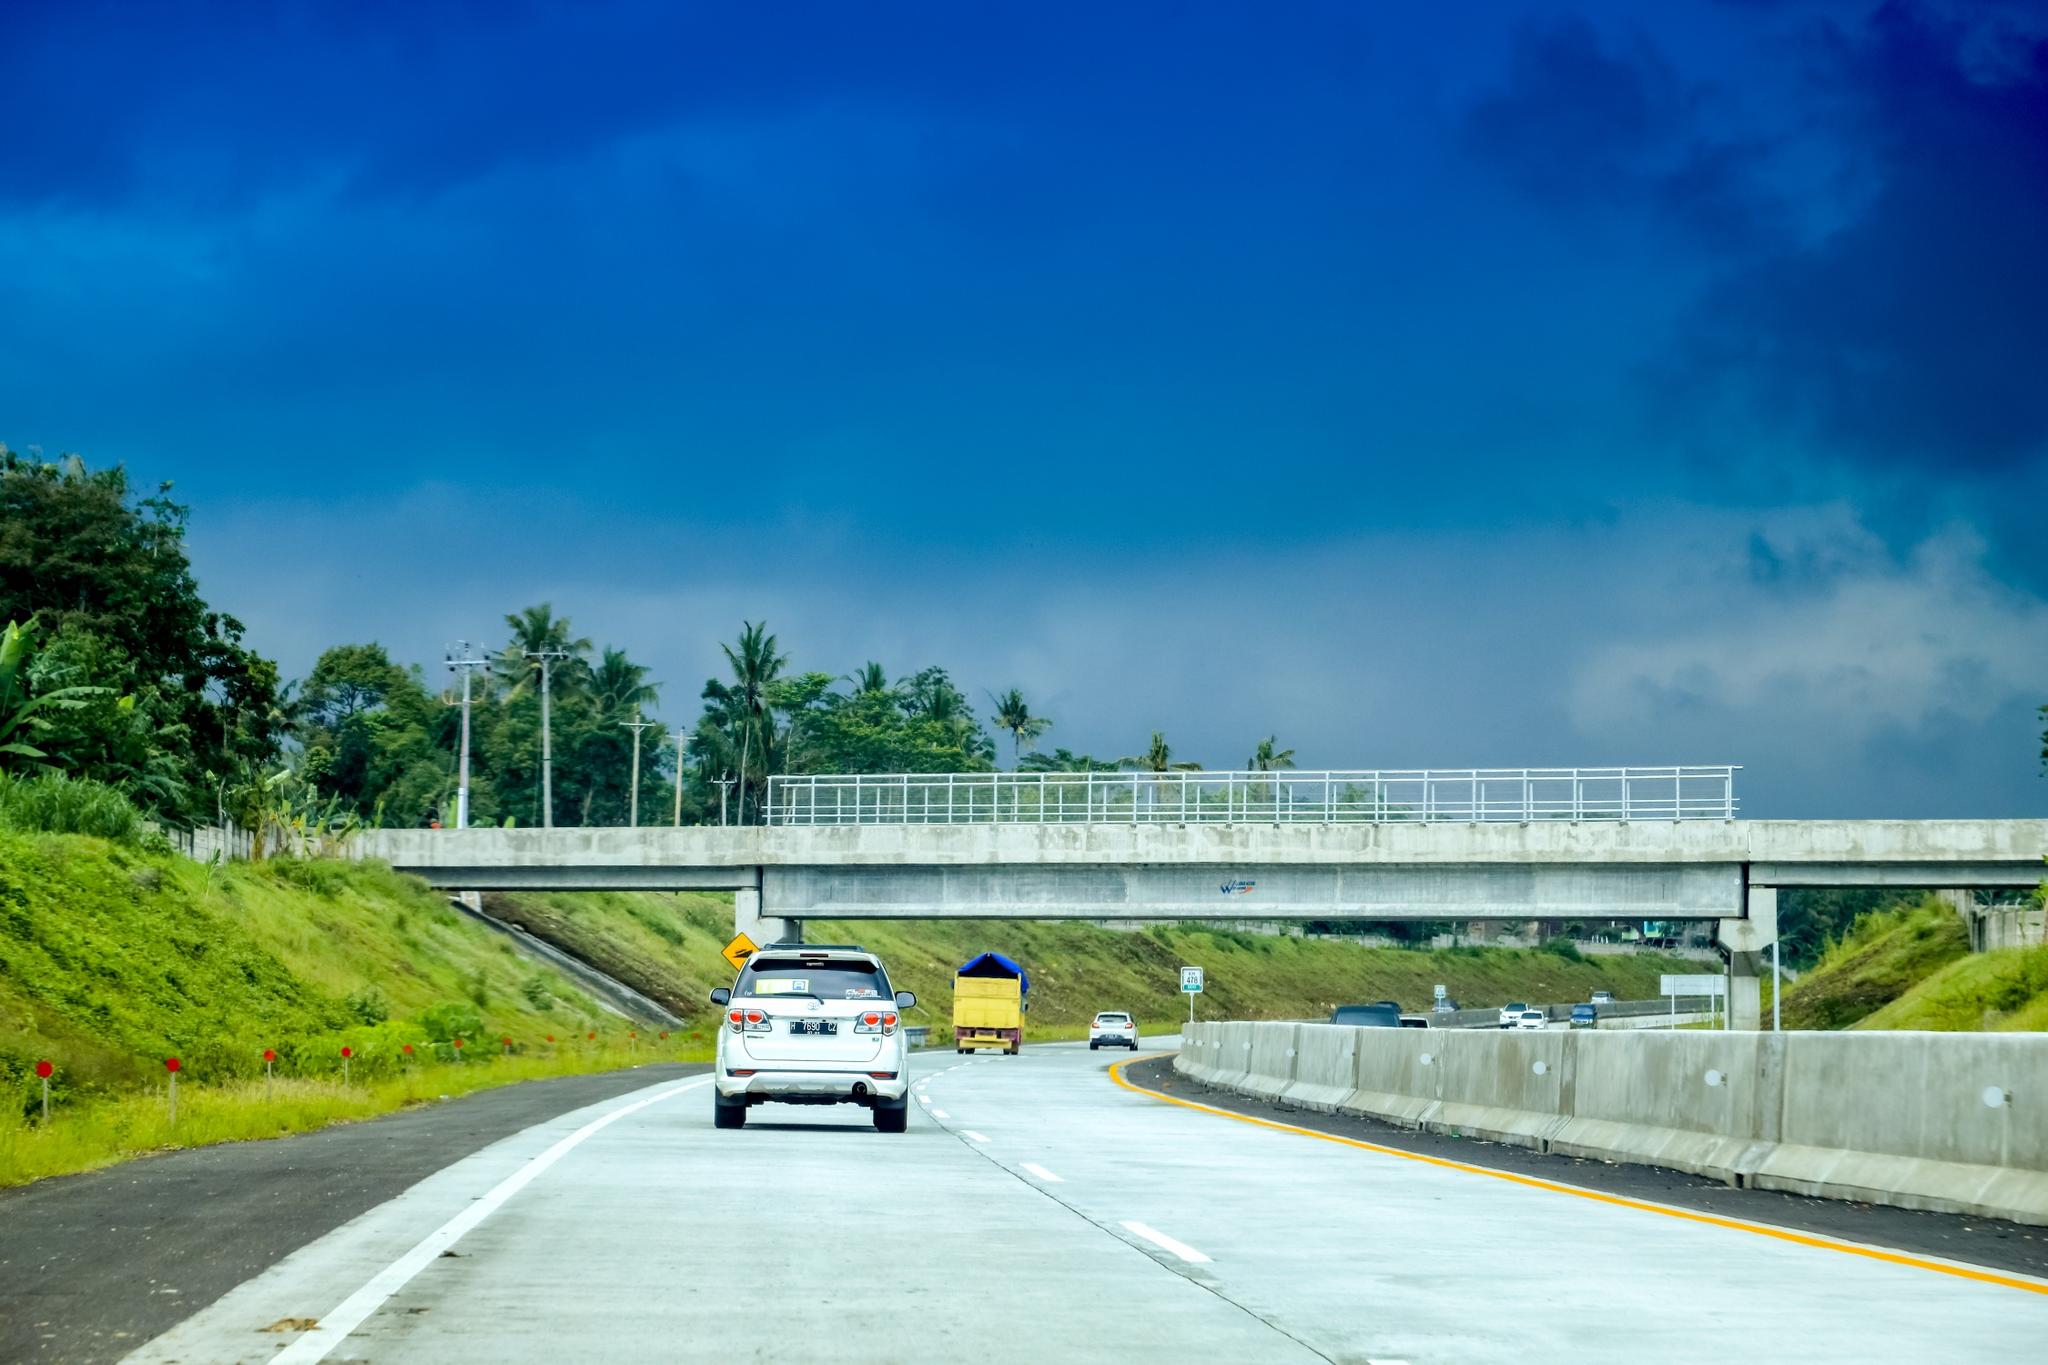What kind of journey do you think awaits someone driving down this highway? This highway in the Philippines likely promises a scenic and relaxing journey. As one drives along, they might encounter more lush greenery and vibrant landscapes, with fields of tropical plants and distant mountain ranges coming into view. Small towns with welcoming locals could dot the pathway, offering glimpses of the rich culture and traditions of the region. The journey feels like an escape into nature, with each bend in the road revealing more of the country's natural beauty. 